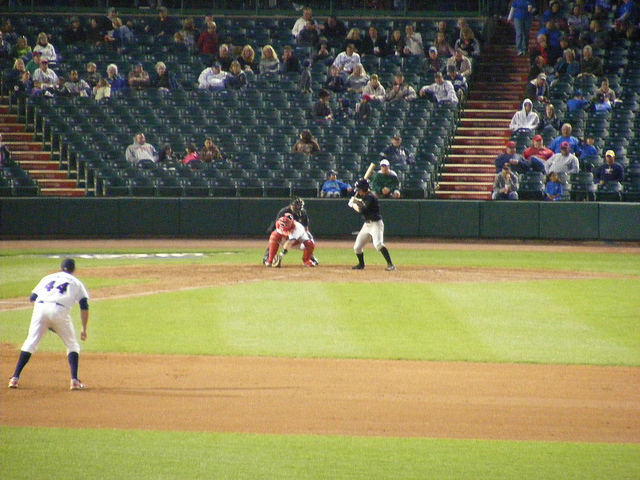Extract all visible text content from this image. 44 